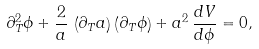Convert formula to latex. <formula><loc_0><loc_0><loc_500><loc_500>\partial ^ { 2 } _ { T } \phi + \frac { 2 } { a } \, \left ( \partial _ { T } a \right ) \left ( \partial _ { T } \phi \right ) + a ^ { 2 } \, \frac { d V } { d \phi } = 0 ,</formula> 